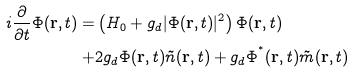Convert formula to latex. <formula><loc_0><loc_0><loc_500><loc_500>i \frac { \partial } { \partial t } \Phi ( { \mathbf r } , t ) = & \left ( H _ { 0 } + g _ { d } | \Phi ( { \mathbf r } , t ) | ^ { 2 } \right ) \Phi ( { \mathbf r } , t ) \\ + & 2 g _ { d } \Phi ( { \mathbf r } , t ) \tilde { n } ( { \mathbf r } , t ) + g _ { d } \Phi ^ { ^ { * } } ( { \mathbf r } , t ) \tilde { m } ( { \mathbf r } , t )</formula> 